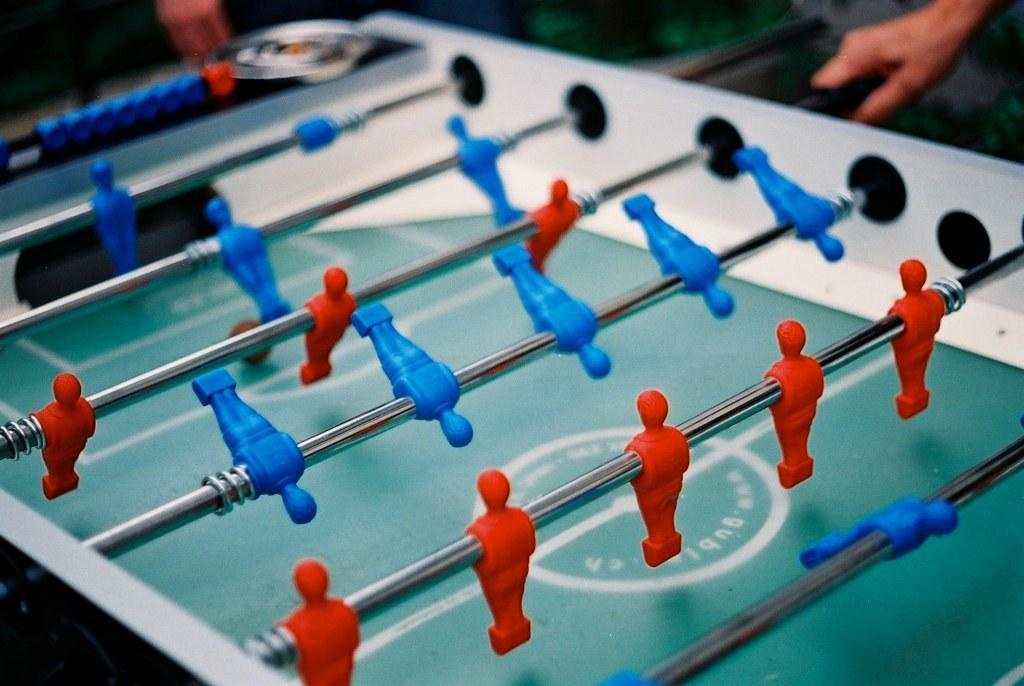Please provide a concise description of this image. In this image we can see a foosball table. At the top we can see a person's hand. 